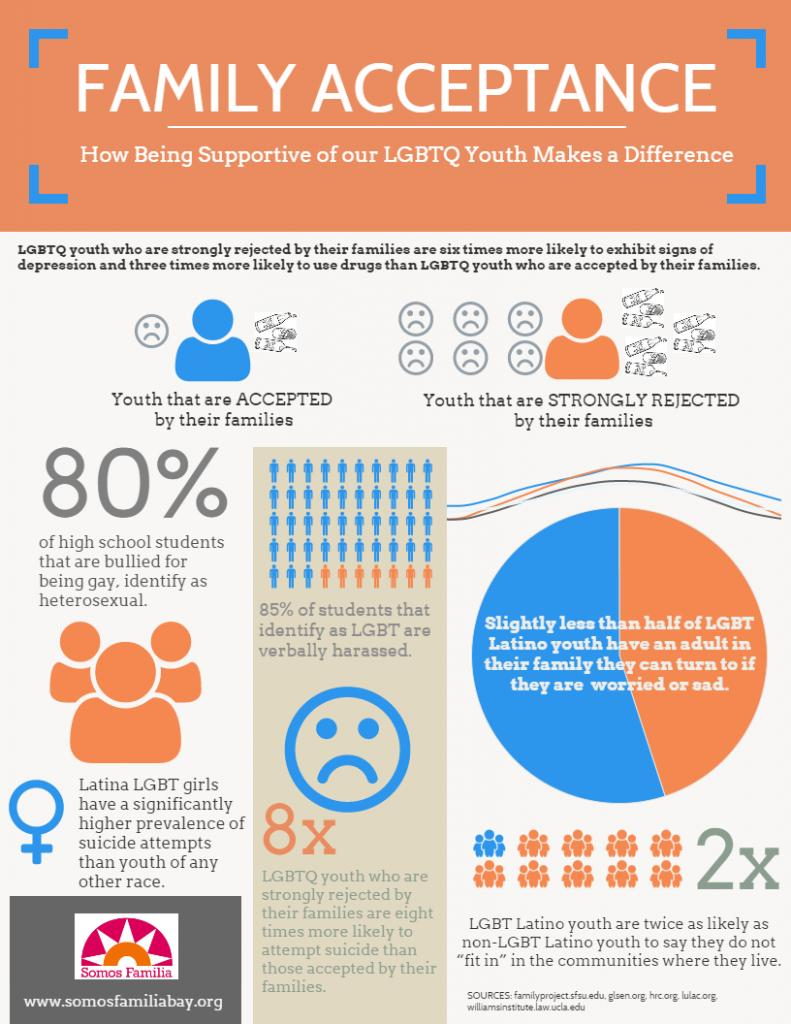Mention a couple of crucial points in this snapshot. According to the study, only 15% of students identified as LGBT reported not having been verbally harassed. It is eight times more likely for someone who has been rejected by their family to attempt suicide than for someone who has not been rejected. According to a recent study, it was found that 80% of students who were bullied for being gay or lesbian are heterosexual. According to research, LGBT Latino youth are twice as likely as other youth to say that they do not fit in. 